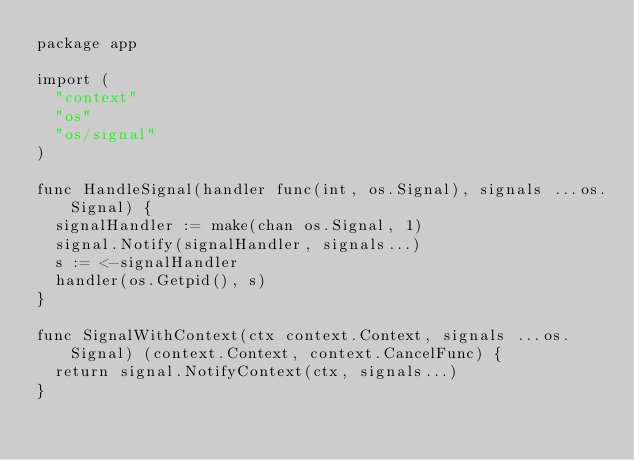Convert code to text. <code><loc_0><loc_0><loc_500><loc_500><_Go_>package app

import (
	"context"
	"os"
	"os/signal"
)

func HandleSignal(handler func(int, os.Signal), signals ...os.Signal) {
	signalHandler := make(chan os.Signal, 1)
	signal.Notify(signalHandler, signals...)
	s := <-signalHandler
	handler(os.Getpid(), s)
}

func SignalWithContext(ctx context.Context, signals ...os.Signal) (context.Context, context.CancelFunc) {
	return signal.NotifyContext(ctx, signals...)
}
</code> 